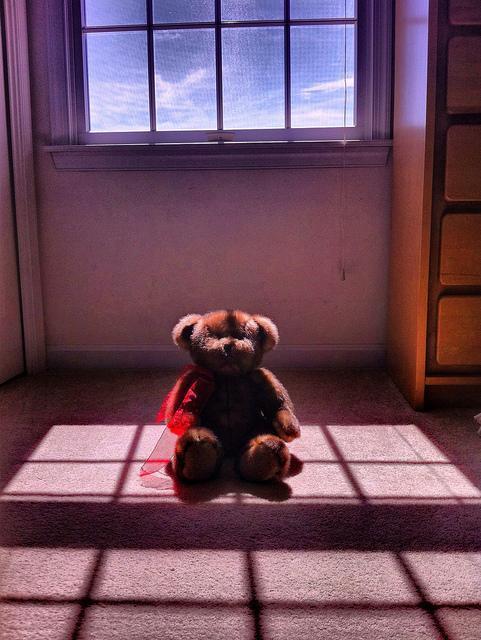How many dogs are on he bench in this image?
Give a very brief answer. 0. 